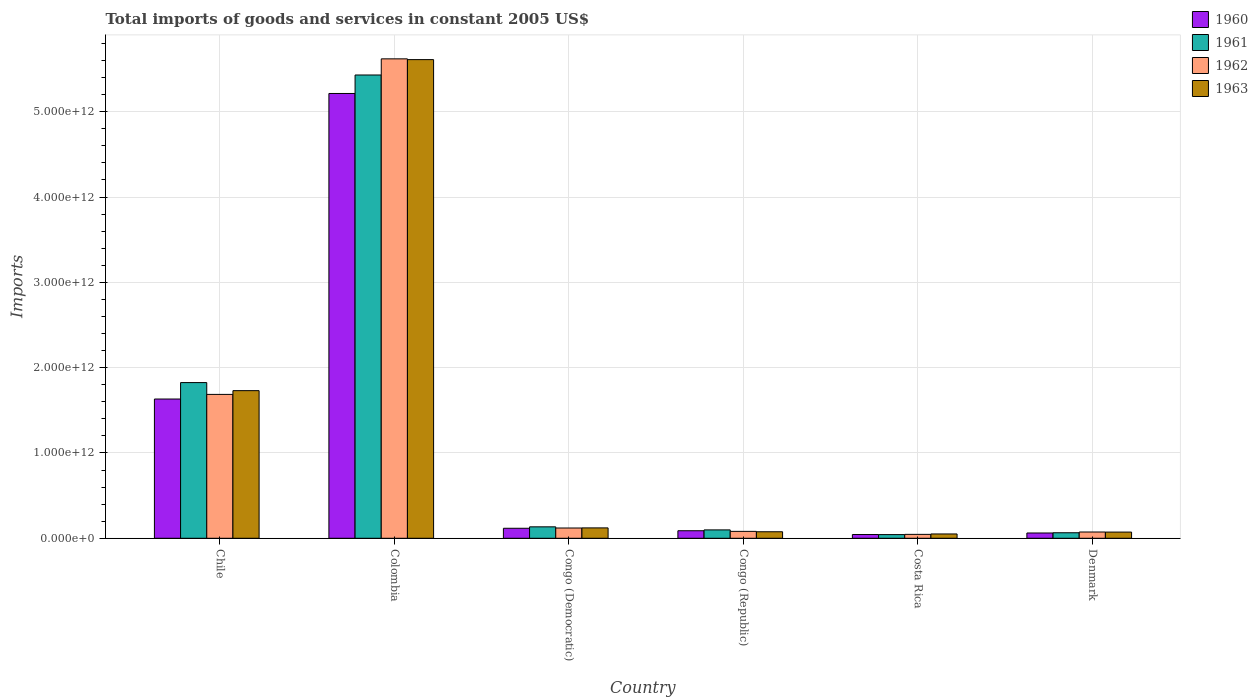How many different coloured bars are there?
Keep it short and to the point. 4. How many groups of bars are there?
Ensure brevity in your answer.  6. Are the number of bars per tick equal to the number of legend labels?
Keep it short and to the point. Yes. What is the label of the 3rd group of bars from the left?
Your response must be concise. Congo (Democratic). What is the total imports of goods and services in 1963 in Colombia?
Give a very brief answer. 5.61e+12. Across all countries, what is the maximum total imports of goods and services in 1963?
Keep it short and to the point. 5.61e+12. Across all countries, what is the minimum total imports of goods and services in 1961?
Keep it short and to the point. 4.30e+1. In which country was the total imports of goods and services in 1960 minimum?
Give a very brief answer. Costa Rica. What is the total total imports of goods and services in 1962 in the graph?
Your answer should be very brief. 7.63e+12. What is the difference between the total imports of goods and services in 1961 in Congo (Republic) and that in Costa Rica?
Keep it short and to the point. 5.52e+1. What is the difference between the total imports of goods and services in 1962 in Denmark and the total imports of goods and services in 1961 in Costa Rica?
Your response must be concise. 3.04e+1. What is the average total imports of goods and services in 1963 per country?
Offer a terse response. 1.28e+12. What is the difference between the total imports of goods and services of/in 1962 and total imports of goods and services of/in 1960 in Congo (Republic)?
Keep it short and to the point. -7.36e+09. What is the ratio of the total imports of goods and services in 1960 in Chile to that in Denmark?
Keep it short and to the point. 26.31. What is the difference between the highest and the second highest total imports of goods and services in 1960?
Give a very brief answer. 5.10e+12. What is the difference between the highest and the lowest total imports of goods and services in 1960?
Offer a very short reply. 5.17e+12. In how many countries, is the total imports of goods and services in 1960 greater than the average total imports of goods and services in 1960 taken over all countries?
Offer a very short reply. 2. Is the sum of the total imports of goods and services in 1961 in Chile and Congo (Democratic) greater than the maximum total imports of goods and services in 1963 across all countries?
Provide a short and direct response. No. Is it the case that in every country, the sum of the total imports of goods and services in 1961 and total imports of goods and services in 1960 is greater than the sum of total imports of goods and services in 1963 and total imports of goods and services in 1962?
Your response must be concise. No. What does the 4th bar from the left in Colombia represents?
Your response must be concise. 1963. What does the 1st bar from the right in Congo (Republic) represents?
Keep it short and to the point. 1963. How many bars are there?
Your answer should be very brief. 24. Are all the bars in the graph horizontal?
Your answer should be very brief. No. How many countries are there in the graph?
Provide a short and direct response. 6. What is the difference between two consecutive major ticks on the Y-axis?
Your answer should be very brief. 1.00e+12. Where does the legend appear in the graph?
Your answer should be compact. Top right. What is the title of the graph?
Provide a short and direct response. Total imports of goods and services in constant 2005 US$. Does "1986" appear as one of the legend labels in the graph?
Offer a very short reply. No. What is the label or title of the X-axis?
Your answer should be very brief. Country. What is the label or title of the Y-axis?
Your answer should be compact. Imports. What is the Imports of 1960 in Chile?
Offer a very short reply. 1.63e+12. What is the Imports of 1961 in Chile?
Give a very brief answer. 1.82e+12. What is the Imports of 1962 in Chile?
Provide a short and direct response. 1.69e+12. What is the Imports in 1963 in Chile?
Ensure brevity in your answer.  1.73e+12. What is the Imports of 1960 in Colombia?
Provide a short and direct response. 5.21e+12. What is the Imports in 1961 in Colombia?
Provide a short and direct response. 5.43e+12. What is the Imports of 1962 in Colombia?
Your answer should be compact. 5.62e+12. What is the Imports in 1963 in Colombia?
Offer a terse response. 5.61e+12. What is the Imports of 1960 in Congo (Democratic)?
Your response must be concise. 1.17e+11. What is the Imports of 1961 in Congo (Democratic)?
Your answer should be very brief. 1.34e+11. What is the Imports of 1962 in Congo (Democratic)?
Offer a very short reply. 1.20e+11. What is the Imports of 1963 in Congo (Democratic)?
Ensure brevity in your answer.  1.22e+11. What is the Imports of 1960 in Congo (Republic)?
Ensure brevity in your answer.  8.83e+1. What is the Imports of 1961 in Congo (Republic)?
Offer a very short reply. 9.83e+1. What is the Imports in 1962 in Congo (Republic)?
Your response must be concise. 8.10e+1. What is the Imports in 1963 in Congo (Republic)?
Your answer should be compact. 7.65e+1. What is the Imports in 1960 in Costa Rica?
Offer a terse response. 4.40e+1. What is the Imports in 1961 in Costa Rica?
Give a very brief answer. 4.30e+1. What is the Imports of 1962 in Costa Rica?
Ensure brevity in your answer.  4.58e+1. What is the Imports of 1963 in Costa Rica?
Make the answer very short. 5.07e+1. What is the Imports of 1960 in Denmark?
Provide a short and direct response. 6.20e+1. What is the Imports in 1961 in Denmark?
Give a very brief answer. 6.48e+1. What is the Imports in 1962 in Denmark?
Keep it short and to the point. 7.35e+1. What is the Imports in 1963 in Denmark?
Your response must be concise. 7.27e+1. Across all countries, what is the maximum Imports of 1960?
Provide a succinct answer. 5.21e+12. Across all countries, what is the maximum Imports in 1961?
Make the answer very short. 5.43e+12. Across all countries, what is the maximum Imports in 1962?
Make the answer very short. 5.62e+12. Across all countries, what is the maximum Imports in 1963?
Ensure brevity in your answer.  5.61e+12. Across all countries, what is the minimum Imports in 1960?
Keep it short and to the point. 4.40e+1. Across all countries, what is the minimum Imports in 1961?
Provide a succinct answer. 4.30e+1. Across all countries, what is the minimum Imports of 1962?
Provide a succinct answer. 4.58e+1. Across all countries, what is the minimum Imports of 1963?
Your answer should be very brief. 5.07e+1. What is the total Imports in 1960 in the graph?
Offer a very short reply. 7.16e+12. What is the total Imports of 1961 in the graph?
Provide a short and direct response. 7.60e+12. What is the total Imports of 1962 in the graph?
Make the answer very short. 7.63e+12. What is the total Imports of 1963 in the graph?
Your response must be concise. 7.66e+12. What is the difference between the Imports in 1960 in Chile and that in Colombia?
Make the answer very short. -3.58e+12. What is the difference between the Imports of 1961 in Chile and that in Colombia?
Offer a very short reply. -3.61e+12. What is the difference between the Imports in 1962 in Chile and that in Colombia?
Keep it short and to the point. -3.93e+12. What is the difference between the Imports in 1963 in Chile and that in Colombia?
Offer a very short reply. -3.88e+12. What is the difference between the Imports of 1960 in Chile and that in Congo (Democratic)?
Your answer should be compact. 1.51e+12. What is the difference between the Imports in 1961 in Chile and that in Congo (Democratic)?
Offer a terse response. 1.69e+12. What is the difference between the Imports in 1962 in Chile and that in Congo (Democratic)?
Offer a very short reply. 1.57e+12. What is the difference between the Imports in 1963 in Chile and that in Congo (Democratic)?
Keep it short and to the point. 1.61e+12. What is the difference between the Imports of 1960 in Chile and that in Congo (Republic)?
Offer a terse response. 1.54e+12. What is the difference between the Imports in 1961 in Chile and that in Congo (Republic)?
Keep it short and to the point. 1.73e+12. What is the difference between the Imports in 1962 in Chile and that in Congo (Republic)?
Provide a short and direct response. 1.61e+12. What is the difference between the Imports of 1963 in Chile and that in Congo (Republic)?
Provide a short and direct response. 1.65e+12. What is the difference between the Imports in 1960 in Chile and that in Costa Rica?
Give a very brief answer. 1.59e+12. What is the difference between the Imports of 1961 in Chile and that in Costa Rica?
Your answer should be compact. 1.78e+12. What is the difference between the Imports in 1962 in Chile and that in Costa Rica?
Your answer should be compact. 1.64e+12. What is the difference between the Imports of 1963 in Chile and that in Costa Rica?
Offer a terse response. 1.68e+12. What is the difference between the Imports of 1960 in Chile and that in Denmark?
Provide a short and direct response. 1.57e+12. What is the difference between the Imports of 1961 in Chile and that in Denmark?
Your answer should be compact. 1.76e+12. What is the difference between the Imports in 1962 in Chile and that in Denmark?
Your response must be concise. 1.61e+12. What is the difference between the Imports in 1963 in Chile and that in Denmark?
Keep it short and to the point. 1.66e+12. What is the difference between the Imports in 1960 in Colombia and that in Congo (Democratic)?
Provide a succinct answer. 5.10e+12. What is the difference between the Imports in 1961 in Colombia and that in Congo (Democratic)?
Offer a terse response. 5.30e+12. What is the difference between the Imports of 1962 in Colombia and that in Congo (Democratic)?
Provide a short and direct response. 5.50e+12. What is the difference between the Imports of 1963 in Colombia and that in Congo (Democratic)?
Offer a very short reply. 5.49e+12. What is the difference between the Imports of 1960 in Colombia and that in Congo (Republic)?
Your response must be concise. 5.13e+12. What is the difference between the Imports in 1961 in Colombia and that in Congo (Republic)?
Provide a short and direct response. 5.33e+12. What is the difference between the Imports of 1962 in Colombia and that in Congo (Republic)?
Your answer should be very brief. 5.54e+12. What is the difference between the Imports in 1963 in Colombia and that in Congo (Republic)?
Offer a very short reply. 5.53e+12. What is the difference between the Imports of 1960 in Colombia and that in Costa Rica?
Provide a succinct answer. 5.17e+12. What is the difference between the Imports of 1961 in Colombia and that in Costa Rica?
Provide a short and direct response. 5.39e+12. What is the difference between the Imports of 1962 in Colombia and that in Costa Rica?
Offer a very short reply. 5.57e+12. What is the difference between the Imports of 1963 in Colombia and that in Costa Rica?
Ensure brevity in your answer.  5.56e+12. What is the difference between the Imports of 1960 in Colombia and that in Denmark?
Provide a short and direct response. 5.15e+12. What is the difference between the Imports in 1961 in Colombia and that in Denmark?
Make the answer very short. 5.37e+12. What is the difference between the Imports in 1962 in Colombia and that in Denmark?
Make the answer very short. 5.55e+12. What is the difference between the Imports in 1963 in Colombia and that in Denmark?
Make the answer very short. 5.54e+12. What is the difference between the Imports in 1960 in Congo (Democratic) and that in Congo (Republic)?
Make the answer very short. 2.90e+1. What is the difference between the Imports in 1961 in Congo (Democratic) and that in Congo (Republic)?
Your response must be concise. 3.59e+1. What is the difference between the Imports of 1962 in Congo (Democratic) and that in Congo (Republic)?
Your response must be concise. 3.95e+1. What is the difference between the Imports of 1963 in Congo (Democratic) and that in Congo (Republic)?
Offer a very short reply. 4.53e+1. What is the difference between the Imports in 1960 in Congo (Democratic) and that in Costa Rica?
Offer a very short reply. 7.34e+1. What is the difference between the Imports of 1961 in Congo (Democratic) and that in Costa Rica?
Offer a very short reply. 9.11e+1. What is the difference between the Imports of 1962 in Congo (Democratic) and that in Costa Rica?
Your response must be concise. 7.47e+1. What is the difference between the Imports of 1963 in Congo (Democratic) and that in Costa Rica?
Ensure brevity in your answer.  7.11e+1. What is the difference between the Imports of 1960 in Congo (Democratic) and that in Denmark?
Offer a terse response. 5.53e+1. What is the difference between the Imports in 1961 in Congo (Democratic) and that in Denmark?
Make the answer very short. 6.94e+1. What is the difference between the Imports in 1962 in Congo (Democratic) and that in Denmark?
Offer a very short reply. 4.70e+1. What is the difference between the Imports of 1963 in Congo (Democratic) and that in Denmark?
Your response must be concise. 4.91e+1. What is the difference between the Imports of 1960 in Congo (Republic) and that in Costa Rica?
Offer a terse response. 4.43e+1. What is the difference between the Imports in 1961 in Congo (Republic) and that in Costa Rica?
Make the answer very short. 5.52e+1. What is the difference between the Imports in 1962 in Congo (Republic) and that in Costa Rica?
Ensure brevity in your answer.  3.52e+1. What is the difference between the Imports of 1963 in Congo (Republic) and that in Costa Rica?
Provide a short and direct response. 2.58e+1. What is the difference between the Imports of 1960 in Congo (Republic) and that in Denmark?
Keep it short and to the point. 2.63e+1. What is the difference between the Imports in 1961 in Congo (Republic) and that in Denmark?
Your response must be concise. 3.35e+1. What is the difference between the Imports in 1962 in Congo (Republic) and that in Denmark?
Give a very brief answer. 7.52e+09. What is the difference between the Imports in 1963 in Congo (Republic) and that in Denmark?
Your answer should be compact. 3.84e+09. What is the difference between the Imports in 1960 in Costa Rica and that in Denmark?
Your response must be concise. -1.80e+1. What is the difference between the Imports of 1961 in Costa Rica and that in Denmark?
Keep it short and to the point. -2.18e+1. What is the difference between the Imports of 1962 in Costa Rica and that in Denmark?
Give a very brief answer. -2.77e+1. What is the difference between the Imports in 1963 in Costa Rica and that in Denmark?
Provide a short and direct response. -2.19e+1. What is the difference between the Imports in 1960 in Chile and the Imports in 1961 in Colombia?
Make the answer very short. -3.80e+12. What is the difference between the Imports of 1960 in Chile and the Imports of 1962 in Colombia?
Your answer should be compact. -3.99e+12. What is the difference between the Imports of 1960 in Chile and the Imports of 1963 in Colombia?
Offer a terse response. -3.98e+12. What is the difference between the Imports in 1961 in Chile and the Imports in 1962 in Colombia?
Make the answer very short. -3.79e+12. What is the difference between the Imports in 1961 in Chile and the Imports in 1963 in Colombia?
Provide a succinct answer. -3.79e+12. What is the difference between the Imports of 1962 in Chile and the Imports of 1963 in Colombia?
Your answer should be very brief. -3.92e+12. What is the difference between the Imports in 1960 in Chile and the Imports in 1961 in Congo (Democratic)?
Your answer should be very brief. 1.50e+12. What is the difference between the Imports in 1960 in Chile and the Imports in 1962 in Congo (Democratic)?
Provide a succinct answer. 1.51e+12. What is the difference between the Imports of 1960 in Chile and the Imports of 1963 in Congo (Democratic)?
Your answer should be very brief. 1.51e+12. What is the difference between the Imports in 1961 in Chile and the Imports in 1962 in Congo (Democratic)?
Give a very brief answer. 1.70e+12. What is the difference between the Imports of 1961 in Chile and the Imports of 1963 in Congo (Democratic)?
Your response must be concise. 1.70e+12. What is the difference between the Imports of 1962 in Chile and the Imports of 1963 in Congo (Democratic)?
Give a very brief answer. 1.56e+12. What is the difference between the Imports in 1960 in Chile and the Imports in 1961 in Congo (Republic)?
Provide a short and direct response. 1.53e+12. What is the difference between the Imports in 1960 in Chile and the Imports in 1962 in Congo (Republic)?
Your answer should be compact. 1.55e+12. What is the difference between the Imports of 1960 in Chile and the Imports of 1963 in Congo (Republic)?
Ensure brevity in your answer.  1.56e+12. What is the difference between the Imports of 1961 in Chile and the Imports of 1962 in Congo (Republic)?
Offer a very short reply. 1.74e+12. What is the difference between the Imports in 1961 in Chile and the Imports in 1963 in Congo (Republic)?
Provide a short and direct response. 1.75e+12. What is the difference between the Imports in 1962 in Chile and the Imports in 1963 in Congo (Republic)?
Provide a short and direct response. 1.61e+12. What is the difference between the Imports of 1960 in Chile and the Imports of 1961 in Costa Rica?
Your response must be concise. 1.59e+12. What is the difference between the Imports in 1960 in Chile and the Imports in 1962 in Costa Rica?
Make the answer very short. 1.59e+12. What is the difference between the Imports of 1960 in Chile and the Imports of 1963 in Costa Rica?
Give a very brief answer. 1.58e+12. What is the difference between the Imports of 1961 in Chile and the Imports of 1962 in Costa Rica?
Your response must be concise. 1.78e+12. What is the difference between the Imports in 1961 in Chile and the Imports in 1963 in Costa Rica?
Offer a very short reply. 1.77e+12. What is the difference between the Imports in 1962 in Chile and the Imports in 1963 in Costa Rica?
Provide a succinct answer. 1.64e+12. What is the difference between the Imports of 1960 in Chile and the Imports of 1961 in Denmark?
Make the answer very short. 1.57e+12. What is the difference between the Imports of 1960 in Chile and the Imports of 1962 in Denmark?
Ensure brevity in your answer.  1.56e+12. What is the difference between the Imports of 1960 in Chile and the Imports of 1963 in Denmark?
Provide a short and direct response. 1.56e+12. What is the difference between the Imports in 1961 in Chile and the Imports in 1962 in Denmark?
Your answer should be very brief. 1.75e+12. What is the difference between the Imports in 1961 in Chile and the Imports in 1963 in Denmark?
Keep it short and to the point. 1.75e+12. What is the difference between the Imports of 1962 in Chile and the Imports of 1963 in Denmark?
Your answer should be very brief. 1.61e+12. What is the difference between the Imports of 1960 in Colombia and the Imports of 1961 in Congo (Democratic)?
Your response must be concise. 5.08e+12. What is the difference between the Imports of 1960 in Colombia and the Imports of 1962 in Congo (Democratic)?
Ensure brevity in your answer.  5.09e+12. What is the difference between the Imports of 1960 in Colombia and the Imports of 1963 in Congo (Democratic)?
Your response must be concise. 5.09e+12. What is the difference between the Imports of 1961 in Colombia and the Imports of 1962 in Congo (Democratic)?
Offer a very short reply. 5.31e+12. What is the difference between the Imports in 1961 in Colombia and the Imports in 1963 in Congo (Democratic)?
Provide a short and direct response. 5.31e+12. What is the difference between the Imports of 1962 in Colombia and the Imports of 1963 in Congo (Democratic)?
Your response must be concise. 5.50e+12. What is the difference between the Imports of 1960 in Colombia and the Imports of 1961 in Congo (Republic)?
Your answer should be very brief. 5.12e+12. What is the difference between the Imports of 1960 in Colombia and the Imports of 1962 in Congo (Republic)?
Your response must be concise. 5.13e+12. What is the difference between the Imports of 1960 in Colombia and the Imports of 1963 in Congo (Republic)?
Your response must be concise. 5.14e+12. What is the difference between the Imports in 1961 in Colombia and the Imports in 1962 in Congo (Republic)?
Ensure brevity in your answer.  5.35e+12. What is the difference between the Imports in 1961 in Colombia and the Imports in 1963 in Congo (Republic)?
Your answer should be very brief. 5.35e+12. What is the difference between the Imports of 1962 in Colombia and the Imports of 1963 in Congo (Republic)?
Provide a succinct answer. 5.54e+12. What is the difference between the Imports in 1960 in Colombia and the Imports in 1961 in Costa Rica?
Keep it short and to the point. 5.17e+12. What is the difference between the Imports in 1960 in Colombia and the Imports in 1962 in Costa Rica?
Ensure brevity in your answer.  5.17e+12. What is the difference between the Imports of 1960 in Colombia and the Imports of 1963 in Costa Rica?
Offer a very short reply. 5.16e+12. What is the difference between the Imports of 1961 in Colombia and the Imports of 1962 in Costa Rica?
Provide a short and direct response. 5.38e+12. What is the difference between the Imports of 1961 in Colombia and the Imports of 1963 in Costa Rica?
Make the answer very short. 5.38e+12. What is the difference between the Imports in 1962 in Colombia and the Imports in 1963 in Costa Rica?
Offer a terse response. 5.57e+12. What is the difference between the Imports in 1960 in Colombia and the Imports in 1961 in Denmark?
Offer a very short reply. 5.15e+12. What is the difference between the Imports of 1960 in Colombia and the Imports of 1962 in Denmark?
Offer a very short reply. 5.14e+12. What is the difference between the Imports of 1960 in Colombia and the Imports of 1963 in Denmark?
Offer a terse response. 5.14e+12. What is the difference between the Imports of 1961 in Colombia and the Imports of 1962 in Denmark?
Offer a terse response. 5.36e+12. What is the difference between the Imports of 1961 in Colombia and the Imports of 1963 in Denmark?
Provide a short and direct response. 5.36e+12. What is the difference between the Imports in 1962 in Colombia and the Imports in 1963 in Denmark?
Make the answer very short. 5.55e+12. What is the difference between the Imports of 1960 in Congo (Democratic) and the Imports of 1961 in Congo (Republic)?
Offer a terse response. 1.91e+1. What is the difference between the Imports in 1960 in Congo (Democratic) and the Imports in 1962 in Congo (Republic)?
Offer a terse response. 3.64e+1. What is the difference between the Imports of 1960 in Congo (Democratic) and the Imports of 1963 in Congo (Republic)?
Offer a very short reply. 4.09e+1. What is the difference between the Imports of 1961 in Congo (Democratic) and the Imports of 1962 in Congo (Republic)?
Ensure brevity in your answer.  5.32e+1. What is the difference between the Imports of 1961 in Congo (Democratic) and the Imports of 1963 in Congo (Republic)?
Offer a very short reply. 5.77e+1. What is the difference between the Imports of 1962 in Congo (Democratic) and the Imports of 1963 in Congo (Republic)?
Provide a succinct answer. 4.40e+1. What is the difference between the Imports in 1960 in Congo (Democratic) and the Imports in 1961 in Costa Rica?
Provide a succinct answer. 7.43e+1. What is the difference between the Imports of 1960 in Congo (Democratic) and the Imports of 1962 in Costa Rica?
Make the answer very short. 7.16e+1. What is the difference between the Imports in 1960 in Congo (Democratic) and the Imports in 1963 in Costa Rica?
Your response must be concise. 6.66e+1. What is the difference between the Imports of 1961 in Congo (Democratic) and the Imports of 1962 in Costa Rica?
Offer a very short reply. 8.84e+1. What is the difference between the Imports in 1961 in Congo (Democratic) and the Imports in 1963 in Costa Rica?
Make the answer very short. 8.34e+1. What is the difference between the Imports of 1962 in Congo (Democratic) and the Imports of 1963 in Costa Rica?
Provide a succinct answer. 6.98e+1. What is the difference between the Imports in 1960 in Congo (Democratic) and the Imports in 1961 in Denmark?
Offer a terse response. 5.26e+1. What is the difference between the Imports of 1960 in Congo (Democratic) and the Imports of 1962 in Denmark?
Offer a very short reply. 4.39e+1. What is the difference between the Imports in 1960 in Congo (Democratic) and the Imports in 1963 in Denmark?
Your answer should be compact. 4.47e+1. What is the difference between the Imports in 1961 in Congo (Democratic) and the Imports in 1962 in Denmark?
Give a very brief answer. 6.07e+1. What is the difference between the Imports of 1961 in Congo (Democratic) and the Imports of 1963 in Denmark?
Provide a succinct answer. 6.15e+1. What is the difference between the Imports in 1962 in Congo (Democratic) and the Imports in 1963 in Denmark?
Your response must be concise. 4.78e+1. What is the difference between the Imports in 1960 in Congo (Republic) and the Imports in 1961 in Costa Rica?
Give a very brief answer. 4.53e+1. What is the difference between the Imports in 1960 in Congo (Republic) and the Imports in 1962 in Costa Rica?
Your response must be concise. 4.26e+1. What is the difference between the Imports in 1960 in Congo (Republic) and the Imports in 1963 in Costa Rica?
Keep it short and to the point. 3.76e+1. What is the difference between the Imports in 1961 in Congo (Republic) and the Imports in 1962 in Costa Rica?
Ensure brevity in your answer.  5.25e+1. What is the difference between the Imports of 1961 in Congo (Republic) and the Imports of 1963 in Costa Rica?
Ensure brevity in your answer.  4.76e+1. What is the difference between the Imports of 1962 in Congo (Republic) and the Imports of 1963 in Costa Rica?
Keep it short and to the point. 3.03e+1. What is the difference between the Imports of 1960 in Congo (Republic) and the Imports of 1961 in Denmark?
Your answer should be very brief. 2.35e+1. What is the difference between the Imports of 1960 in Congo (Republic) and the Imports of 1962 in Denmark?
Provide a short and direct response. 1.49e+1. What is the difference between the Imports of 1960 in Congo (Republic) and the Imports of 1963 in Denmark?
Make the answer very short. 1.57e+1. What is the difference between the Imports in 1961 in Congo (Republic) and the Imports in 1962 in Denmark?
Ensure brevity in your answer.  2.48e+1. What is the difference between the Imports in 1961 in Congo (Republic) and the Imports in 1963 in Denmark?
Offer a terse response. 2.56e+1. What is the difference between the Imports in 1962 in Congo (Republic) and the Imports in 1963 in Denmark?
Make the answer very short. 8.32e+09. What is the difference between the Imports in 1960 in Costa Rica and the Imports in 1961 in Denmark?
Ensure brevity in your answer.  -2.08e+1. What is the difference between the Imports of 1960 in Costa Rica and the Imports of 1962 in Denmark?
Make the answer very short. -2.95e+1. What is the difference between the Imports in 1960 in Costa Rica and the Imports in 1963 in Denmark?
Your response must be concise. -2.87e+1. What is the difference between the Imports of 1961 in Costa Rica and the Imports of 1962 in Denmark?
Your answer should be compact. -3.04e+1. What is the difference between the Imports of 1961 in Costa Rica and the Imports of 1963 in Denmark?
Your response must be concise. -2.96e+1. What is the difference between the Imports of 1962 in Costa Rica and the Imports of 1963 in Denmark?
Keep it short and to the point. -2.69e+1. What is the average Imports in 1960 per country?
Give a very brief answer. 1.19e+12. What is the average Imports in 1961 per country?
Offer a terse response. 1.27e+12. What is the average Imports in 1962 per country?
Ensure brevity in your answer.  1.27e+12. What is the average Imports of 1963 per country?
Ensure brevity in your answer.  1.28e+12. What is the difference between the Imports in 1960 and Imports in 1961 in Chile?
Give a very brief answer. -1.93e+11. What is the difference between the Imports of 1960 and Imports of 1962 in Chile?
Give a very brief answer. -5.42e+1. What is the difference between the Imports of 1960 and Imports of 1963 in Chile?
Your answer should be compact. -9.81e+1. What is the difference between the Imports in 1961 and Imports in 1962 in Chile?
Your answer should be compact. 1.39e+11. What is the difference between the Imports in 1961 and Imports in 1963 in Chile?
Give a very brief answer. 9.46e+1. What is the difference between the Imports in 1962 and Imports in 1963 in Chile?
Ensure brevity in your answer.  -4.39e+1. What is the difference between the Imports of 1960 and Imports of 1961 in Colombia?
Keep it short and to the point. -2.17e+11. What is the difference between the Imports in 1960 and Imports in 1962 in Colombia?
Offer a very short reply. -4.06e+11. What is the difference between the Imports of 1960 and Imports of 1963 in Colombia?
Ensure brevity in your answer.  -3.97e+11. What is the difference between the Imports in 1961 and Imports in 1962 in Colombia?
Your response must be concise. -1.89e+11. What is the difference between the Imports in 1961 and Imports in 1963 in Colombia?
Give a very brief answer. -1.80e+11. What is the difference between the Imports in 1962 and Imports in 1963 in Colombia?
Make the answer very short. 9.11e+09. What is the difference between the Imports in 1960 and Imports in 1961 in Congo (Democratic)?
Ensure brevity in your answer.  -1.68e+1. What is the difference between the Imports in 1960 and Imports in 1962 in Congo (Democratic)?
Your answer should be very brief. -3.13e+09. What is the difference between the Imports of 1960 and Imports of 1963 in Congo (Democratic)?
Keep it short and to the point. -4.41e+09. What is the difference between the Imports of 1961 and Imports of 1962 in Congo (Democratic)?
Give a very brief answer. 1.37e+1. What is the difference between the Imports of 1961 and Imports of 1963 in Congo (Democratic)?
Your answer should be very brief. 1.24e+1. What is the difference between the Imports in 1962 and Imports in 1963 in Congo (Democratic)?
Give a very brief answer. -1.28e+09. What is the difference between the Imports in 1960 and Imports in 1961 in Congo (Republic)?
Your answer should be very brief. -9.92e+09. What is the difference between the Imports of 1960 and Imports of 1962 in Congo (Republic)?
Ensure brevity in your answer.  7.36e+09. What is the difference between the Imports of 1960 and Imports of 1963 in Congo (Republic)?
Make the answer very short. 1.18e+1. What is the difference between the Imports of 1961 and Imports of 1962 in Congo (Republic)?
Ensure brevity in your answer.  1.73e+1. What is the difference between the Imports of 1961 and Imports of 1963 in Congo (Republic)?
Keep it short and to the point. 2.18e+1. What is the difference between the Imports of 1962 and Imports of 1963 in Congo (Republic)?
Ensure brevity in your answer.  4.48e+09. What is the difference between the Imports in 1960 and Imports in 1961 in Costa Rica?
Provide a succinct answer. 9.75e+08. What is the difference between the Imports in 1960 and Imports in 1962 in Costa Rica?
Make the answer very short. -1.77e+09. What is the difference between the Imports in 1960 and Imports in 1963 in Costa Rica?
Ensure brevity in your answer.  -6.71e+09. What is the difference between the Imports of 1961 and Imports of 1962 in Costa Rica?
Give a very brief answer. -2.75e+09. What is the difference between the Imports of 1961 and Imports of 1963 in Costa Rica?
Give a very brief answer. -7.69e+09. What is the difference between the Imports in 1962 and Imports in 1963 in Costa Rica?
Offer a terse response. -4.94e+09. What is the difference between the Imports in 1960 and Imports in 1961 in Denmark?
Provide a succinct answer. -2.76e+09. What is the difference between the Imports in 1960 and Imports in 1962 in Denmark?
Ensure brevity in your answer.  -1.14e+1. What is the difference between the Imports in 1960 and Imports in 1963 in Denmark?
Ensure brevity in your answer.  -1.06e+1. What is the difference between the Imports in 1961 and Imports in 1962 in Denmark?
Your answer should be very brief. -8.66e+09. What is the difference between the Imports in 1961 and Imports in 1963 in Denmark?
Give a very brief answer. -7.86e+09. What is the difference between the Imports in 1962 and Imports in 1963 in Denmark?
Your response must be concise. 8.02e+08. What is the ratio of the Imports in 1960 in Chile to that in Colombia?
Offer a very short reply. 0.31. What is the ratio of the Imports in 1961 in Chile to that in Colombia?
Make the answer very short. 0.34. What is the ratio of the Imports of 1962 in Chile to that in Colombia?
Offer a very short reply. 0.3. What is the ratio of the Imports of 1963 in Chile to that in Colombia?
Provide a succinct answer. 0.31. What is the ratio of the Imports of 1960 in Chile to that in Congo (Democratic)?
Make the answer very short. 13.91. What is the ratio of the Imports in 1961 in Chile to that in Congo (Democratic)?
Provide a short and direct response. 13.6. What is the ratio of the Imports in 1962 in Chile to that in Congo (Democratic)?
Provide a short and direct response. 14. What is the ratio of the Imports in 1963 in Chile to that in Congo (Democratic)?
Keep it short and to the point. 14.21. What is the ratio of the Imports in 1960 in Chile to that in Congo (Republic)?
Provide a succinct answer. 18.47. What is the ratio of the Imports of 1961 in Chile to that in Congo (Republic)?
Keep it short and to the point. 18.57. What is the ratio of the Imports of 1962 in Chile to that in Congo (Republic)?
Your response must be concise. 20.82. What is the ratio of the Imports of 1963 in Chile to that in Congo (Republic)?
Make the answer very short. 22.62. What is the ratio of the Imports of 1960 in Chile to that in Costa Rica?
Your answer should be compact. 37.09. What is the ratio of the Imports in 1961 in Chile to that in Costa Rica?
Provide a short and direct response. 42.41. What is the ratio of the Imports in 1962 in Chile to that in Costa Rica?
Offer a terse response. 36.84. What is the ratio of the Imports in 1963 in Chile to that in Costa Rica?
Keep it short and to the point. 34.12. What is the ratio of the Imports of 1960 in Chile to that in Denmark?
Provide a succinct answer. 26.31. What is the ratio of the Imports of 1961 in Chile to that in Denmark?
Give a very brief answer. 28.16. What is the ratio of the Imports of 1962 in Chile to that in Denmark?
Provide a short and direct response. 22.96. What is the ratio of the Imports in 1963 in Chile to that in Denmark?
Keep it short and to the point. 23.81. What is the ratio of the Imports of 1960 in Colombia to that in Congo (Democratic)?
Offer a terse response. 44.42. What is the ratio of the Imports in 1961 in Colombia to that in Congo (Democratic)?
Keep it short and to the point. 40.47. What is the ratio of the Imports of 1962 in Colombia to that in Congo (Democratic)?
Keep it short and to the point. 46.63. What is the ratio of the Imports of 1963 in Colombia to that in Congo (Democratic)?
Provide a short and direct response. 46.07. What is the ratio of the Imports in 1960 in Colombia to that in Congo (Republic)?
Offer a very short reply. 59.01. What is the ratio of the Imports of 1961 in Colombia to that in Congo (Republic)?
Offer a very short reply. 55.26. What is the ratio of the Imports of 1962 in Colombia to that in Congo (Republic)?
Offer a very short reply. 69.39. What is the ratio of the Imports in 1963 in Colombia to that in Congo (Republic)?
Give a very brief answer. 73.33. What is the ratio of the Imports in 1960 in Colombia to that in Costa Rica?
Your response must be concise. 118.47. What is the ratio of the Imports of 1961 in Colombia to that in Costa Rica?
Offer a very short reply. 126.19. What is the ratio of the Imports in 1962 in Colombia to that in Costa Rica?
Your answer should be very brief. 122.75. What is the ratio of the Imports in 1963 in Colombia to that in Costa Rica?
Make the answer very short. 110.62. What is the ratio of the Imports of 1960 in Colombia to that in Denmark?
Offer a very short reply. 84.03. What is the ratio of the Imports of 1961 in Colombia to that in Denmark?
Give a very brief answer. 83.8. What is the ratio of the Imports of 1962 in Colombia to that in Denmark?
Provide a succinct answer. 76.49. What is the ratio of the Imports of 1963 in Colombia to that in Denmark?
Ensure brevity in your answer.  77.21. What is the ratio of the Imports of 1960 in Congo (Democratic) to that in Congo (Republic)?
Keep it short and to the point. 1.33. What is the ratio of the Imports of 1961 in Congo (Democratic) to that in Congo (Republic)?
Offer a very short reply. 1.37. What is the ratio of the Imports in 1962 in Congo (Democratic) to that in Congo (Republic)?
Offer a terse response. 1.49. What is the ratio of the Imports of 1963 in Congo (Democratic) to that in Congo (Republic)?
Your answer should be very brief. 1.59. What is the ratio of the Imports of 1960 in Congo (Democratic) to that in Costa Rica?
Provide a succinct answer. 2.67. What is the ratio of the Imports in 1961 in Congo (Democratic) to that in Costa Rica?
Your response must be concise. 3.12. What is the ratio of the Imports of 1962 in Congo (Democratic) to that in Costa Rica?
Give a very brief answer. 2.63. What is the ratio of the Imports of 1963 in Congo (Democratic) to that in Costa Rica?
Your answer should be very brief. 2.4. What is the ratio of the Imports in 1960 in Congo (Democratic) to that in Denmark?
Provide a succinct answer. 1.89. What is the ratio of the Imports of 1961 in Congo (Democratic) to that in Denmark?
Keep it short and to the point. 2.07. What is the ratio of the Imports of 1962 in Congo (Democratic) to that in Denmark?
Your response must be concise. 1.64. What is the ratio of the Imports in 1963 in Congo (Democratic) to that in Denmark?
Offer a terse response. 1.68. What is the ratio of the Imports of 1960 in Congo (Republic) to that in Costa Rica?
Keep it short and to the point. 2.01. What is the ratio of the Imports of 1961 in Congo (Republic) to that in Costa Rica?
Provide a succinct answer. 2.28. What is the ratio of the Imports of 1962 in Congo (Republic) to that in Costa Rica?
Keep it short and to the point. 1.77. What is the ratio of the Imports in 1963 in Congo (Republic) to that in Costa Rica?
Offer a very short reply. 1.51. What is the ratio of the Imports in 1960 in Congo (Republic) to that in Denmark?
Ensure brevity in your answer.  1.42. What is the ratio of the Imports in 1961 in Congo (Republic) to that in Denmark?
Give a very brief answer. 1.52. What is the ratio of the Imports of 1962 in Congo (Republic) to that in Denmark?
Ensure brevity in your answer.  1.1. What is the ratio of the Imports of 1963 in Congo (Republic) to that in Denmark?
Your answer should be very brief. 1.05. What is the ratio of the Imports of 1960 in Costa Rica to that in Denmark?
Keep it short and to the point. 0.71. What is the ratio of the Imports in 1961 in Costa Rica to that in Denmark?
Your response must be concise. 0.66. What is the ratio of the Imports in 1962 in Costa Rica to that in Denmark?
Your response must be concise. 0.62. What is the ratio of the Imports of 1963 in Costa Rica to that in Denmark?
Offer a very short reply. 0.7. What is the difference between the highest and the second highest Imports in 1960?
Provide a succinct answer. 3.58e+12. What is the difference between the highest and the second highest Imports of 1961?
Offer a very short reply. 3.61e+12. What is the difference between the highest and the second highest Imports in 1962?
Give a very brief answer. 3.93e+12. What is the difference between the highest and the second highest Imports in 1963?
Your answer should be compact. 3.88e+12. What is the difference between the highest and the lowest Imports in 1960?
Provide a succinct answer. 5.17e+12. What is the difference between the highest and the lowest Imports in 1961?
Your answer should be very brief. 5.39e+12. What is the difference between the highest and the lowest Imports of 1962?
Offer a terse response. 5.57e+12. What is the difference between the highest and the lowest Imports in 1963?
Offer a terse response. 5.56e+12. 